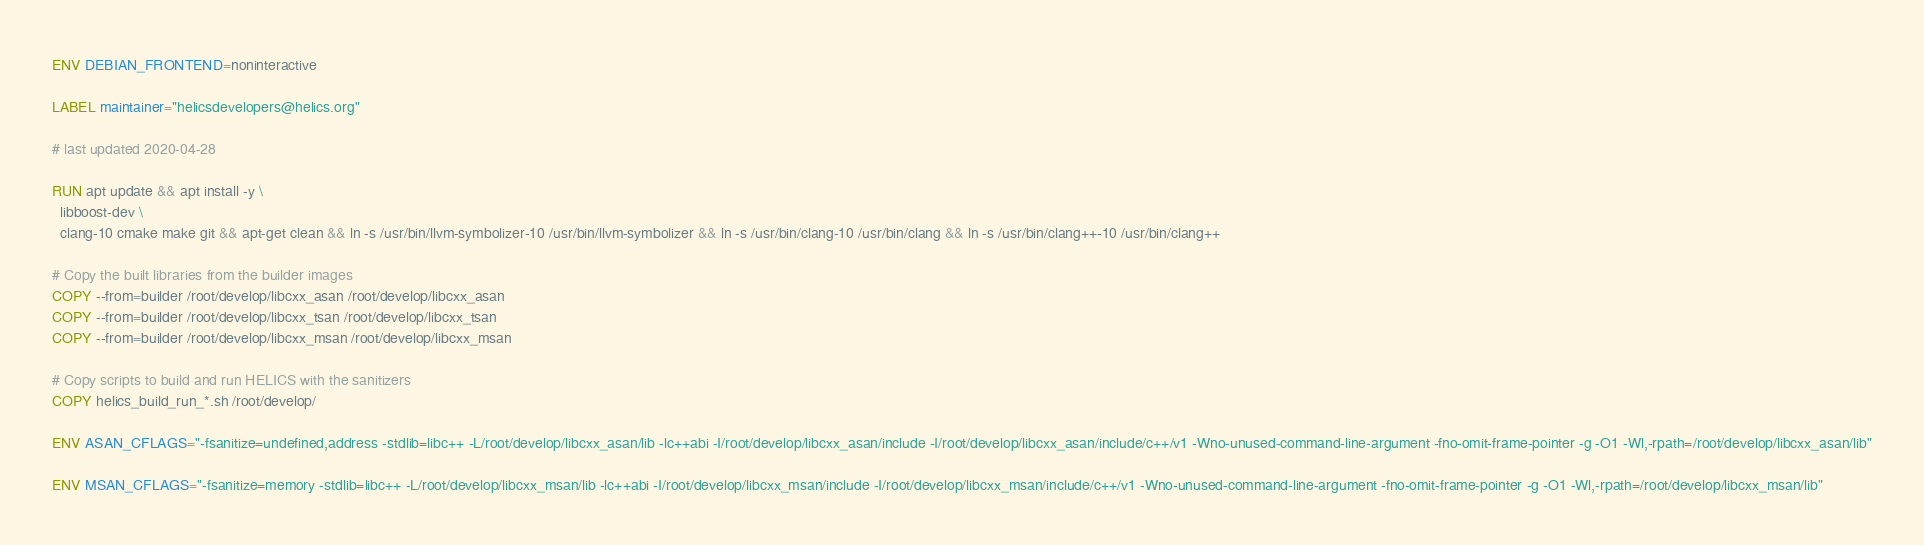<code> <loc_0><loc_0><loc_500><loc_500><_Dockerfile_>
ENV DEBIAN_FRONTEND=noninteractive

LABEL maintainer="helicsdevelopers@helics.org"

# last updated 2020-04-28

RUN apt update && apt install -y \
  libboost-dev \
  clang-10 cmake make git && apt-get clean && ln -s /usr/bin/llvm-symbolizer-10 /usr/bin/llvm-symbolizer && ln -s /usr/bin/clang-10 /usr/bin/clang && ln -s /usr/bin/clang++-10 /usr/bin/clang++

# Copy the built libraries from the builder images
COPY --from=builder /root/develop/libcxx_asan /root/develop/libcxx_asan
COPY --from=builder /root/develop/libcxx_tsan /root/develop/libcxx_tsan
COPY --from=builder /root/develop/libcxx_msan /root/develop/libcxx_msan

# Copy scripts to build and run HELICS with the sanitizers
COPY helics_build_run_*.sh /root/develop/

ENV ASAN_CFLAGS="-fsanitize=undefined,address -stdlib=libc++ -L/root/develop/libcxx_asan/lib -lc++abi -I/root/develop/libcxx_asan/include -I/root/develop/libcxx_asan/include/c++/v1 -Wno-unused-command-line-argument -fno-omit-frame-pointer -g -O1 -Wl,-rpath=/root/develop/libcxx_asan/lib"

ENV MSAN_CFLAGS="-fsanitize=memory -stdlib=libc++ -L/root/develop/libcxx_msan/lib -lc++abi -I/root/develop/libcxx_msan/include -I/root/develop/libcxx_msan/include/c++/v1 -Wno-unused-command-line-argument -fno-omit-frame-pointer -g -O1 -Wl,-rpath=/root/develop/libcxx_msan/lib"
</code> 